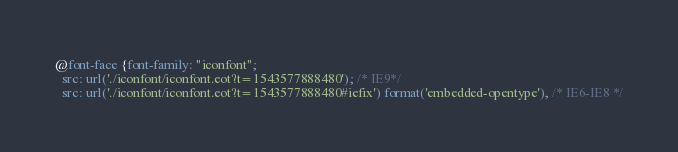<code> <loc_0><loc_0><loc_500><loc_500><_CSS_>
@font-face {font-family: "iconfont";
  src: url('./iconfont/iconfont.eot?t=1543577888480'); /* IE9*/
  src: url('./iconfont/iconfont.eot?t=1543577888480#iefix') format('embedded-opentype'), /* IE6-IE8 */</code> 